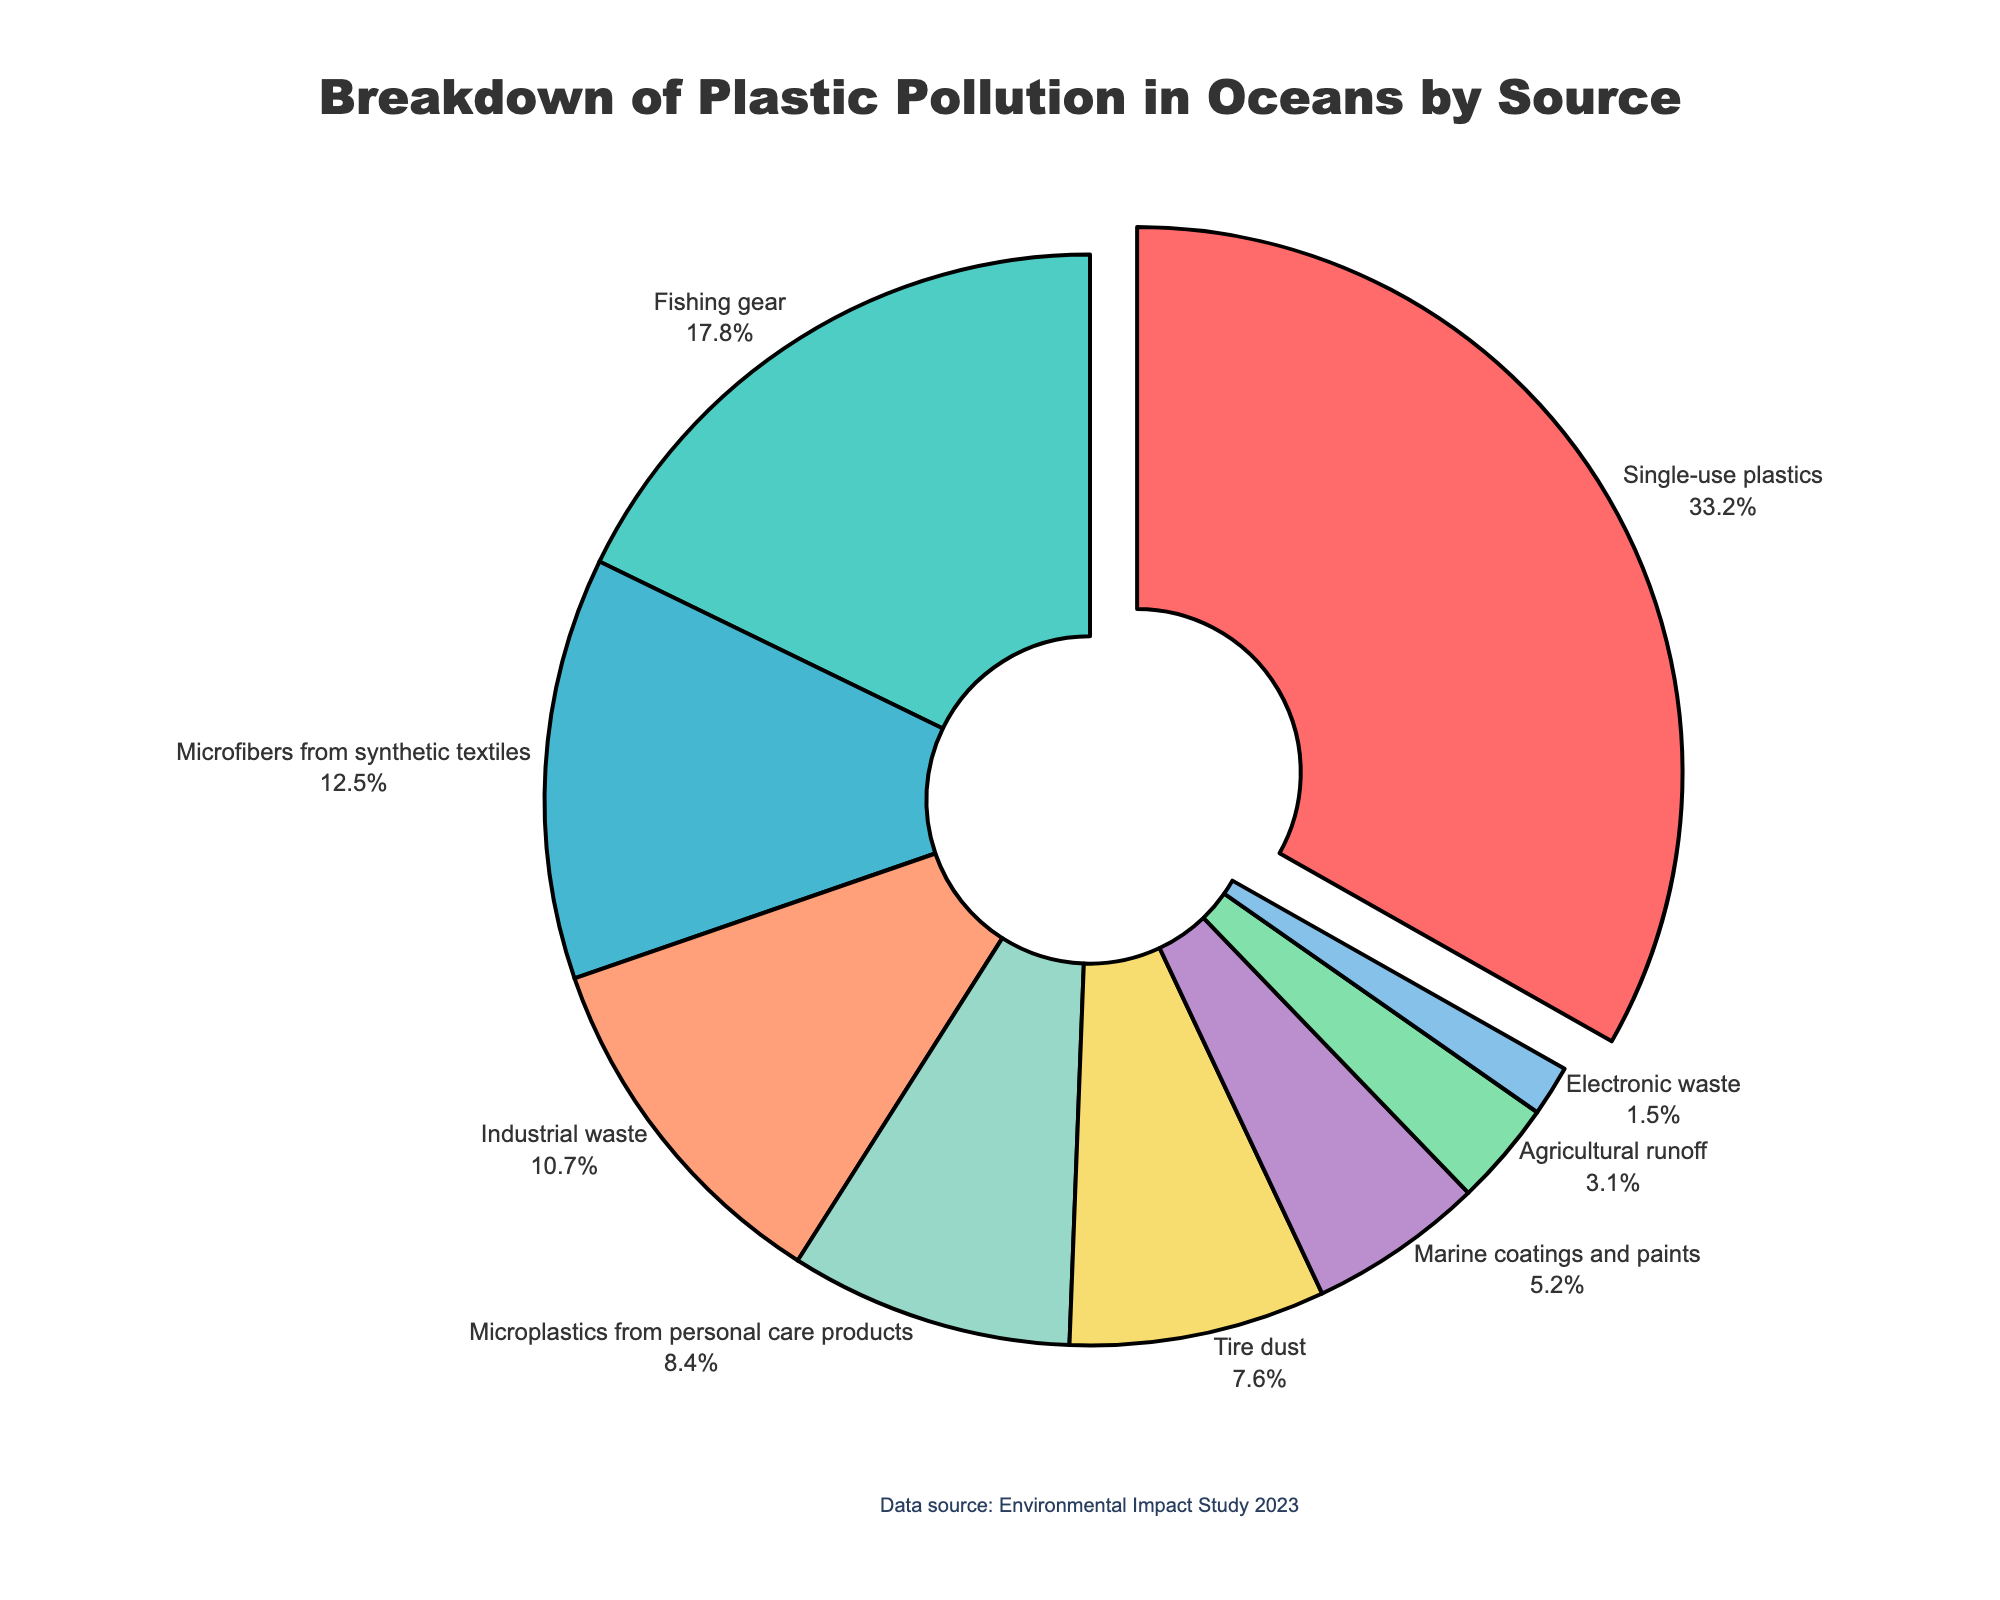Which source of plastic pollution contributes the most to the ocean? The slice with the highest percentage represents the greatest contribution to ocean plastic pollution, which is labeled "Single-use plastics" with 33.2%.
Answer: Single-use plastics How much more do single-use plastics contribute to ocean pollution compared to fishing gear? The difference between single-use plastics (33.2%) and fishing gear (17.8%) is calculated by subtracting 17.8 from 33.2.
Answer: 15.4% Which sources contribute less than 10% to ocean plastic pollution? The slices representing less than 10% are: Industrial waste (10.7%) is just over 10%, so it doesn't qualify. Others like Microplastics from personal care products (8.4%), Tire dust (7.6%), Marine coatings and paints (5.2%), Agricultural runoff (3.1%), and Electronic waste (1.5%) are below 10%.
Answer: Microplastics from personal care products, Tire dust, Marine coatings and paints, Agricultural runoff, Electronic waste What is the combined percentage of pollution from microfibers from synthetic textiles and microplastics from personal care products? Adding the percentages of microfibers from synthetic textiles (12.5%) and microplastics from personal care products (8.4%) gives a combined value.
Answer: 20.9% Is the contribution of industrial waste greater than marine coatings and paints? By comparing the two percentages, Industrial waste (10.7%) is greater than Marine coatings and paints (5.2%).
Answer: Yes Which source has the smallest contribution to ocean plastic pollution? The smallest slice with the lowest percentage is labeled "Electronic waste" with 1.5%.
Answer: Electronic waste What is the average percentage contribution of all sources listed? Sum all percentages and divide by the number of sources: (33.2 + 17.8 + 12.5 + 10.7 + 8.4 + 7.6 + 5.2 + 3.1 + 1.5) / 9.
Answer: 11.1% Is the percentage of plastic pollution from agricultural runoff less than half the percentage of industrial waste? Half the percentage of industrial waste (10.7%) is 5.35%, and agricultural runoff (3.1%) is less than 5.35%.
Answer: Yes What is the total percentage of pollution contributed by sources other than single-use plastics and fishing gear combined? Subtract the sum of the percentages of single-use plastics (33.2%) and fishing gear (17.8%) from 100%: 100 - 33.2 - 17.8.
Answer: 49% What color represents the largest source of plastic pollution? The color representing the largest slice, which is single-use plastics (33.2%), is described as red in the pie chart.
Answer: Red 